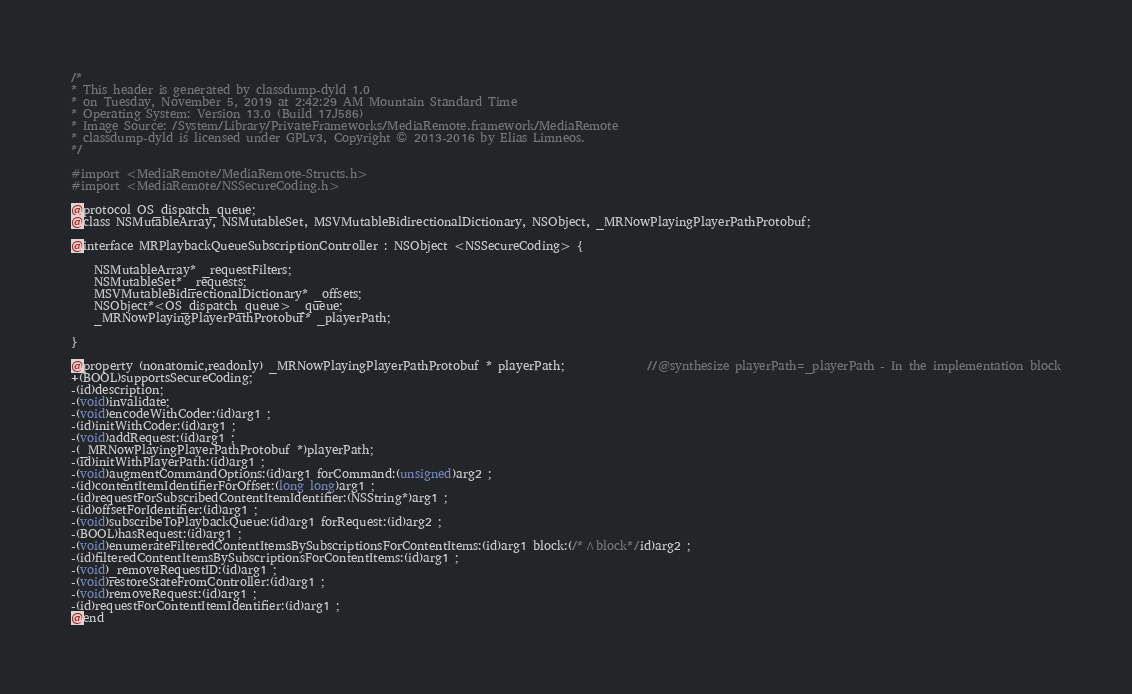Convert code to text. <code><loc_0><loc_0><loc_500><loc_500><_C_>/*
* This header is generated by classdump-dyld 1.0
* on Tuesday, November 5, 2019 at 2:42:29 AM Mountain Standard Time
* Operating System: Version 13.0 (Build 17J586)
* Image Source: /System/Library/PrivateFrameworks/MediaRemote.framework/MediaRemote
* classdump-dyld is licensed under GPLv3, Copyright © 2013-2016 by Elias Limneos.
*/

#import <MediaRemote/MediaRemote-Structs.h>
#import <MediaRemote/NSSecureCoding.h>

@protocol OS_dispatch_queue;
@class NSMutableArray, NSMutableSet, MSVMutableBidirectionalDictionary, NSObject, _MRNowPlayingPlayerPathProtobuf;

@interface MRPlaybackQueueSubscriptionController : NSObject <NSSecureCoding> {

	NSMutableArray* _requestFilters;
	NSMutableSet* _requests;
	MSVMutableBidirectionalDictionary* _offsets;
	NSObject*<OS_dispatch_queue> _queue;
	_MRNowPlayingPlayerPathProtobuf* _playerPath;

}

@property (nonatomic,readonly) _MRNowPlayingPlayerPathProtobuf * playerPath;              //@synthesize playerPath=_playerPath - In the implementation block
+(BOOL)supportsSecureCoding;
-(id)description;
-(void)invalidate;
-(void)encodeWithCoder:(id)arg1 ;
-(id)initWithCoder:(id)arg1 ;
-(void)addRequest:(id)arg1 ;
-(_MRNowPlayingPlayerPathProtobuf *)playerPath;
-(id)initWithPlayerPath:(id)arg1 ;
-(void)augmentCommandOptions:(id)arg1 forCommand:(unsigned)arg2 ;
-(id)contentItemIdentifierForOffset:(long long)arg1 ;
-(id)requestForSubscribedContentItemIdentifier:(NSString*)arg1 ;
-(id)offsetForIdentifier:(id)arg1 ;
-(void)subscribeToPlaybackQueue:(id)arg1 forRequest:(id)arg2 ;
-(BOOL)hasRequest:(id)arg1 ;
-(void)enumerateFilteredContentItemsBySubscriptionsForContentItems:(id)arg1 block:(/*^block*/id)arg2 ;
-(id)filteredContentItemsBySubscriptionsForContentItems:(id)arg1 ;
-(void)_removeRequestID:(id)arg1 ;
-(void)restoreStateFromController:(id)arg1 ;
-(void)removeRequest:(id)arg1 ;
-(id)requestForContentItemIdentifier:(id)arg1 ;
@end

</code> 